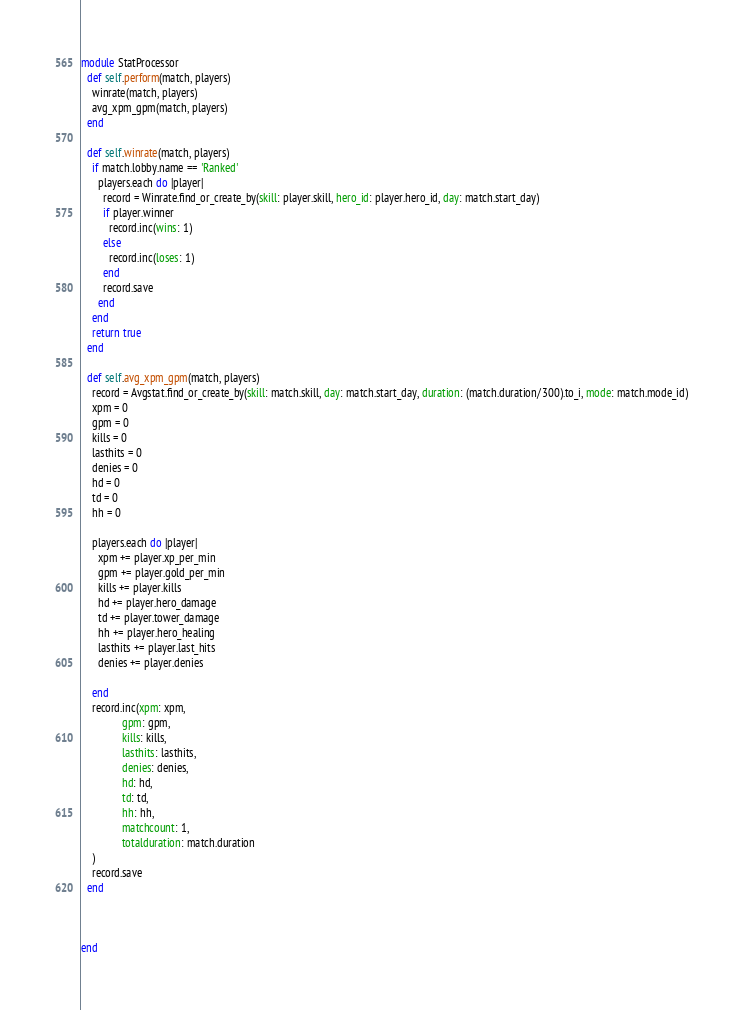<code> <loc_0><loc_0><loc_500><loc_500><_Ruby_>module StatProcessor
  def self.perform(match, players)
    winrate(match, players)
    avg_xpm_gpm(match, players)
  end

  def self.winrate(match, players)
    if match.lobby.name == 'Ranked'
      players.each do |player|
        record = Winrate.find_or_create_by(skill: player.skill, hero_id: player.hero_id, day: match.start_day)
        if player.winner
          record.inc(wins: 1)
        else
          record.inc(loses: 1)
        end
        record.save
      end
    end
    return true
  end

  def self.avg_xpm_gpm(match, players)
    record = Avgstat.find_or_create_by(skill: match.skill, day: match.start_day, duration: (match.duration/300).to_i, mode: match.mode_id)
    xpm = 0
    gpm = 0
    kills = 0
    lasthits = 0
    denies = 0
    hd = 0
    td = 0
    hh = 0

    players.each do |player|
      xpm += player.xp_per_min
      gpm += player.gold_per_min
      kills += player.kills
      hd += player.hero_damage
      td += player.tower_damage
      hh += player.hero_healing
      lasthits += player.last_hits
      denies += player.denies

    end
    record.inc(xpm: xpm,
               gpm: gpm,
               kills: kills,
               lasthits: lasthits,
               denies: denies,
               hd: hd,
               td: td,
               hh: hh,
               matchcount: 1,
               totalduration: match.duration
    )
    record.save
  end



end
</code> 